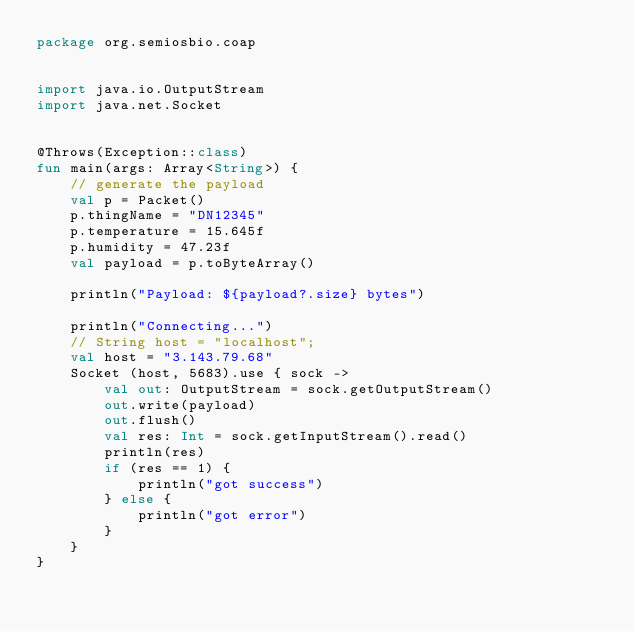Convert code to text. <code><loc_0><loc_0><loc_500><loc_500><_Kotlin_>package org.semiosbio.coap


import java.io.OutputStream
import java.net.Socket


@Throws(Exception::class)
fun main(args: Array<String>) {
    // generate the payload
    val p = Packet()
    p.thingName = "DN12345"
    p.temperature = 15.645f
    p.humidity = 47.23f
    val payload = p.toByteArray()

    println("Payload: ${payload?.size} bytes")

    println("Connecting...")
    // String host = "localhost";
    val host = "3.143.79.68"
    Socket (host, 5683).use { sock ->
        val out: OutputStream = sock.getOutputStream()
        out.write(payload)
        out.flush()
        val res: Int = sock.getInputStream().read()
        println(res)
        if (res == 1) {
            println("got success")
        } else {
            println("got error")
        }
    }
}</code> 